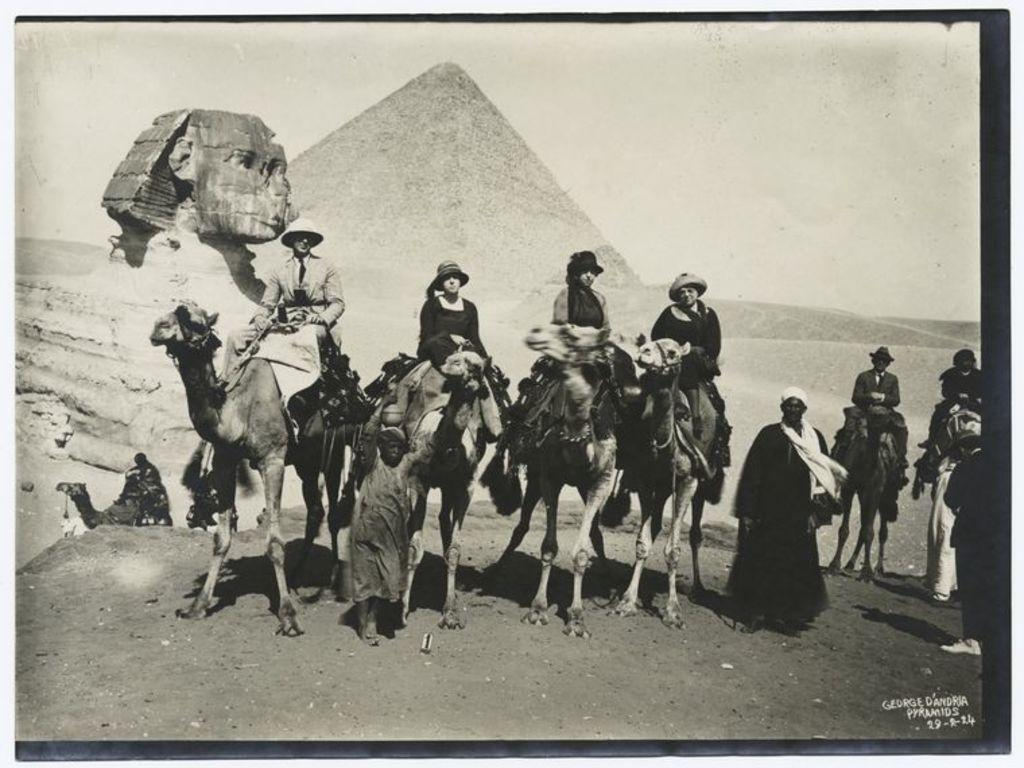What is the color scheme of the image? The image is black and white. What can be seen in the foreground of the image? There are people and camels in the foreground of the image. What is visible in the background of the image? There are sculptures and a pyramid in the background of the image. What is the weather like in the image? The sky is sunny in the image. What type of surprise can be seen in the image? There is no surprise present in the image; it features people, camels, sculptures, a pyramid, and a sunny sky. Can you tell me how many times the people in the image are rubbing their hands together? There is no indication in the image that the people are rubbing their hands together, so it cannot be determined from the picture. 